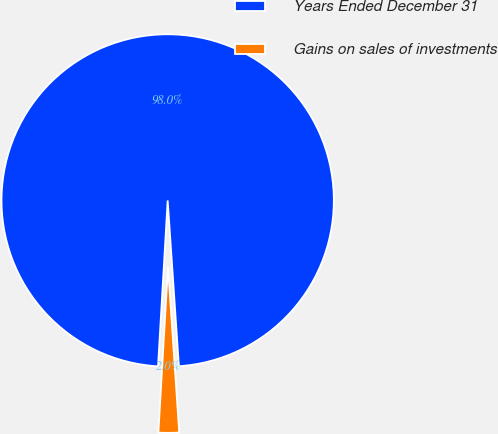<chart> <loc_0><loc_0><loc_500><loc_500><pie_chart><fcel>Years Ended December 31<fcel>Gains on sales of investments<nl><fcel>98.0%<fcel>2.0%<nl></chart> 